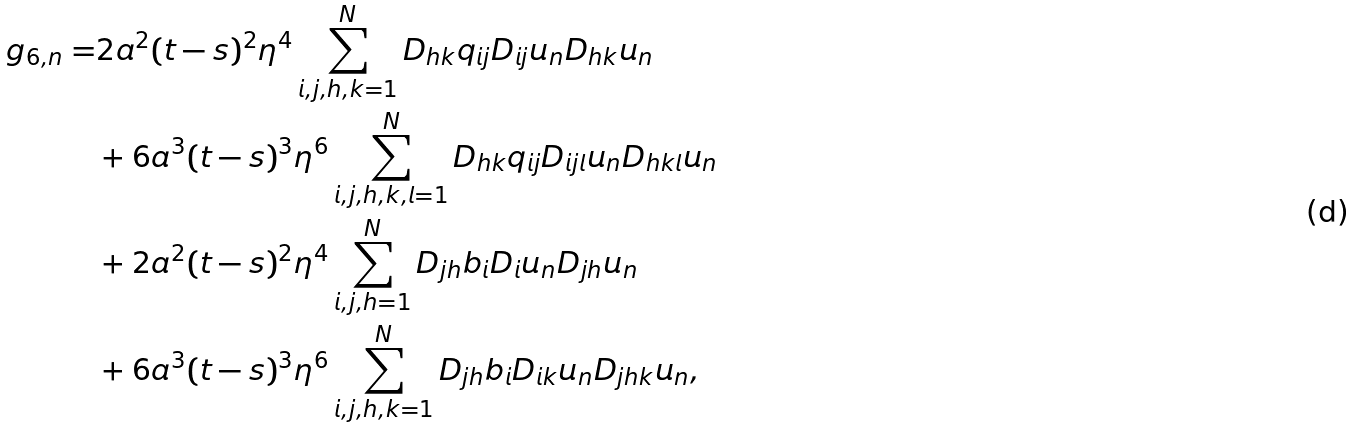Convert formula to latex. <formula><loc_0><loc_0><loc_500><loc_500>g _ { 6 , n } = & 2 a ^ { 2 } ( t - s ) ^ { 2 } \eta ^ { 4 } \sum _ { i , j , h , k = 1 } ^ { N } D _ { h k } q _ { i j } D _ { i j } u _ { n } D _ { h k } u _ { n } \\ & + 6 a ^ { 3 } ( t - s ) ^ { 3 } \eta ^ { 6 } \sum _ { i , j , h , k , l = 1 } ^ { N } D _ { h k } q _ { i j } D _ { i j l } u _ { n } D _ { h k l } u _ { n } \\ & + 2 a ^ { 2 } ( t - s ) ^ { 2 } \eta ^ { 4 } \sum _ { i , j , h = 1 } ^ { N } D _ { j h } b _ { i } D _ { i } u _ { n } D _ { j h } u _ { n } \\ & + 6 a ^ { 3 } ( t - s ) ^ { 3 } \eta ^ { 6 } \sum _ { i , j , h , k = 1 } ^ { N } D _ { j h } b _ { i } D _ { i k } u _ { n } D _ { j h k } u _ { n } ,</formula> 